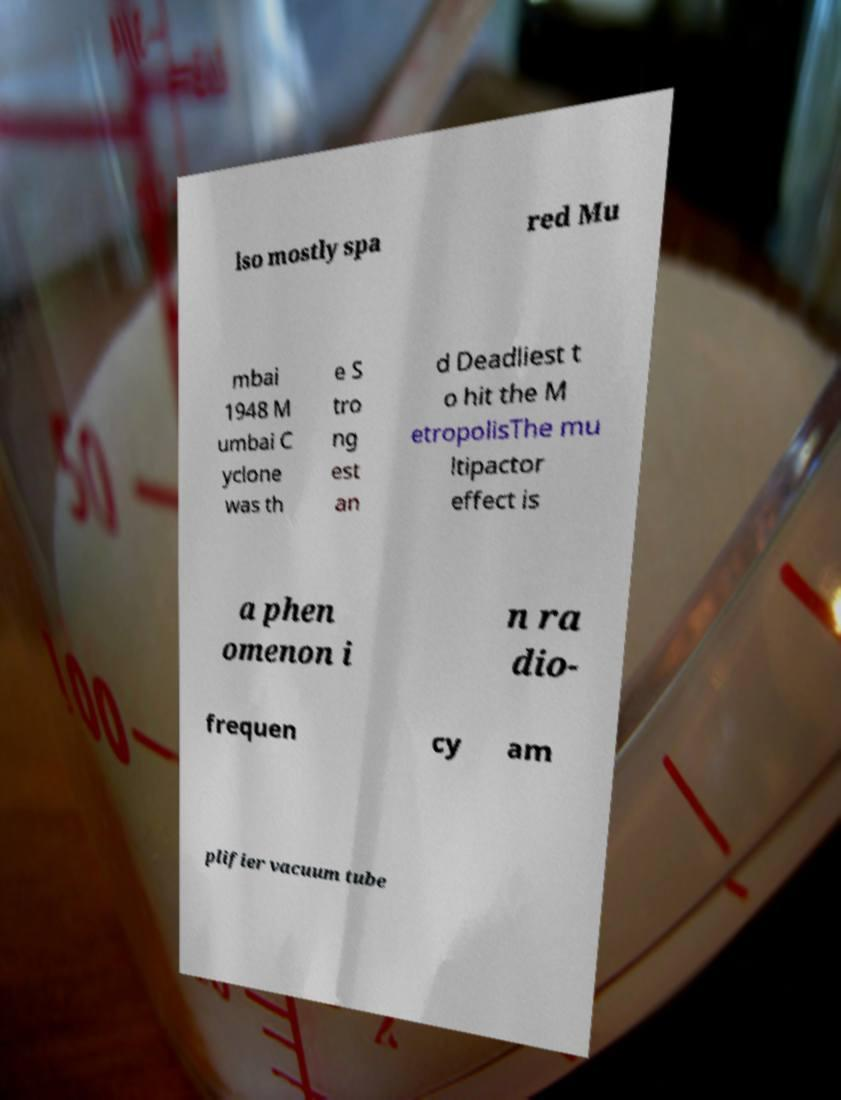Can you read and provide the text displayed in the image?This photo seems to have some interesting text. Can you extract and type it out for me? lso mostly spa red Mu mbai 1948 M umbai C yclone was th e S tro ng est an d Deadliest t o hit the M etropolisThe mu ltipactor effect is a phen omenon i n ra dio- frequen cy am plifier vacuum tube 